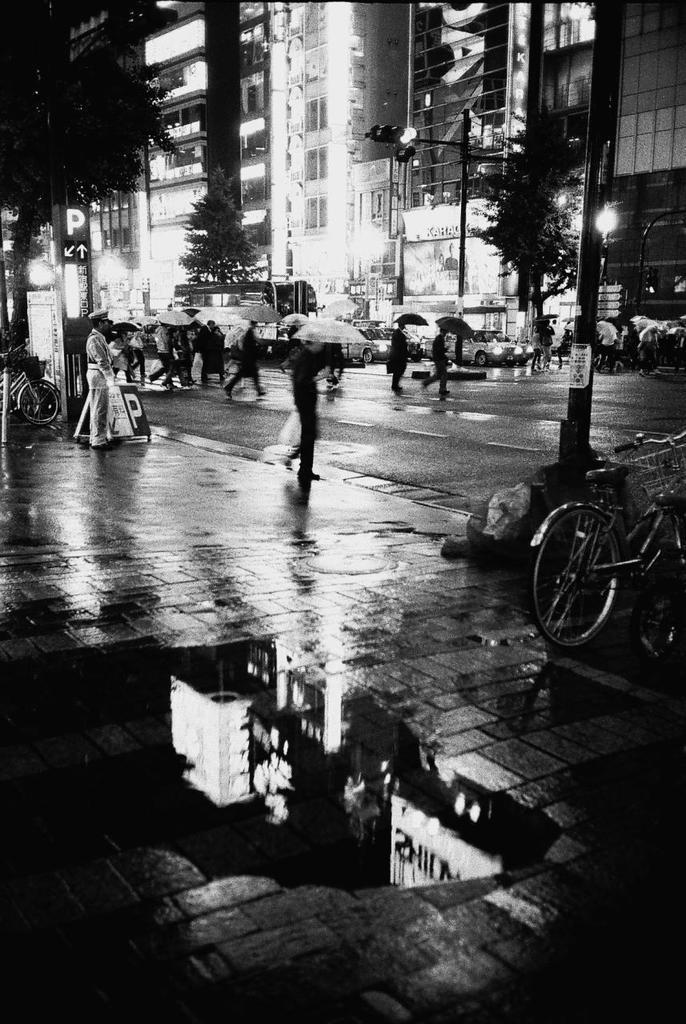Describe this image in one or two sentences. This is a black and white image where we can see a pavement, poles, lights, trees, buildings, cars and people on the road. We can see few people are holding umbrellas in their hands. On the both sides of the image, we can see bicycles. We can see water on the pavement. 